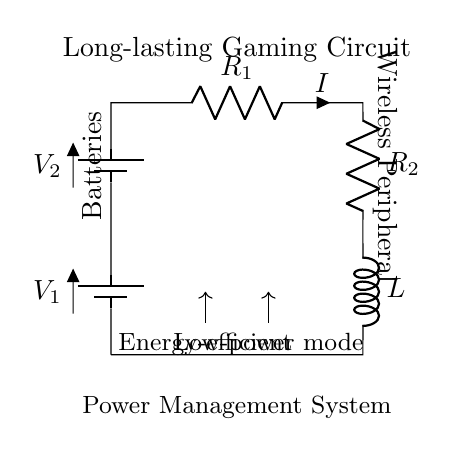What type of components are used in this circuit? The circuit contains two batteries, two resistors, and one inductor, which are the main components used to create a long-lasting power supply for a wireless peripheral.
Answer: batteries, resistors, inductor What is the role of the inductor in this circuit? Inductors typically store energy in a magnetic field when current passes through them, and in this circuit, it helps to manage energy flow and maintain a stable current to the wireless peripheral.
Answer: energy management How many batteries are in series in this circuit? There are two batteries connected in series. The circuit diagram visibly shows two battery symbols stacked on top of each other, indicating their series connection.
Answer: two What is the notation for current in this circuit? The current flowing through the resistors in the circuit is denoted by the letter 'I', which is marked alongside the resistor symbol.
Answer: I What is the total resistance in this circuit? To find the total resistance, you would add the resistance values of the two resistors located in series in the circuit. However, since the specific resistance values are not given in the visual, we can state that the total resistance is the sum of R1 and R2.
Answer: R1 + R2 What does the “Power Management System” label indicate? The label highlights the part of the circuit responsible for managing energy consumption and efficiency, particularly in terms of ensuring low power usage during operation to extend the battery life of the gaming peripherals.
Answer: energy efficiency In which direction does energy flow in this circuit? Energy flows from the top battery down through the circuit, passing through both the resistors and inductor, before returning to the bottom battery, illustrating a complete loop for current flow.
Answer: downward 